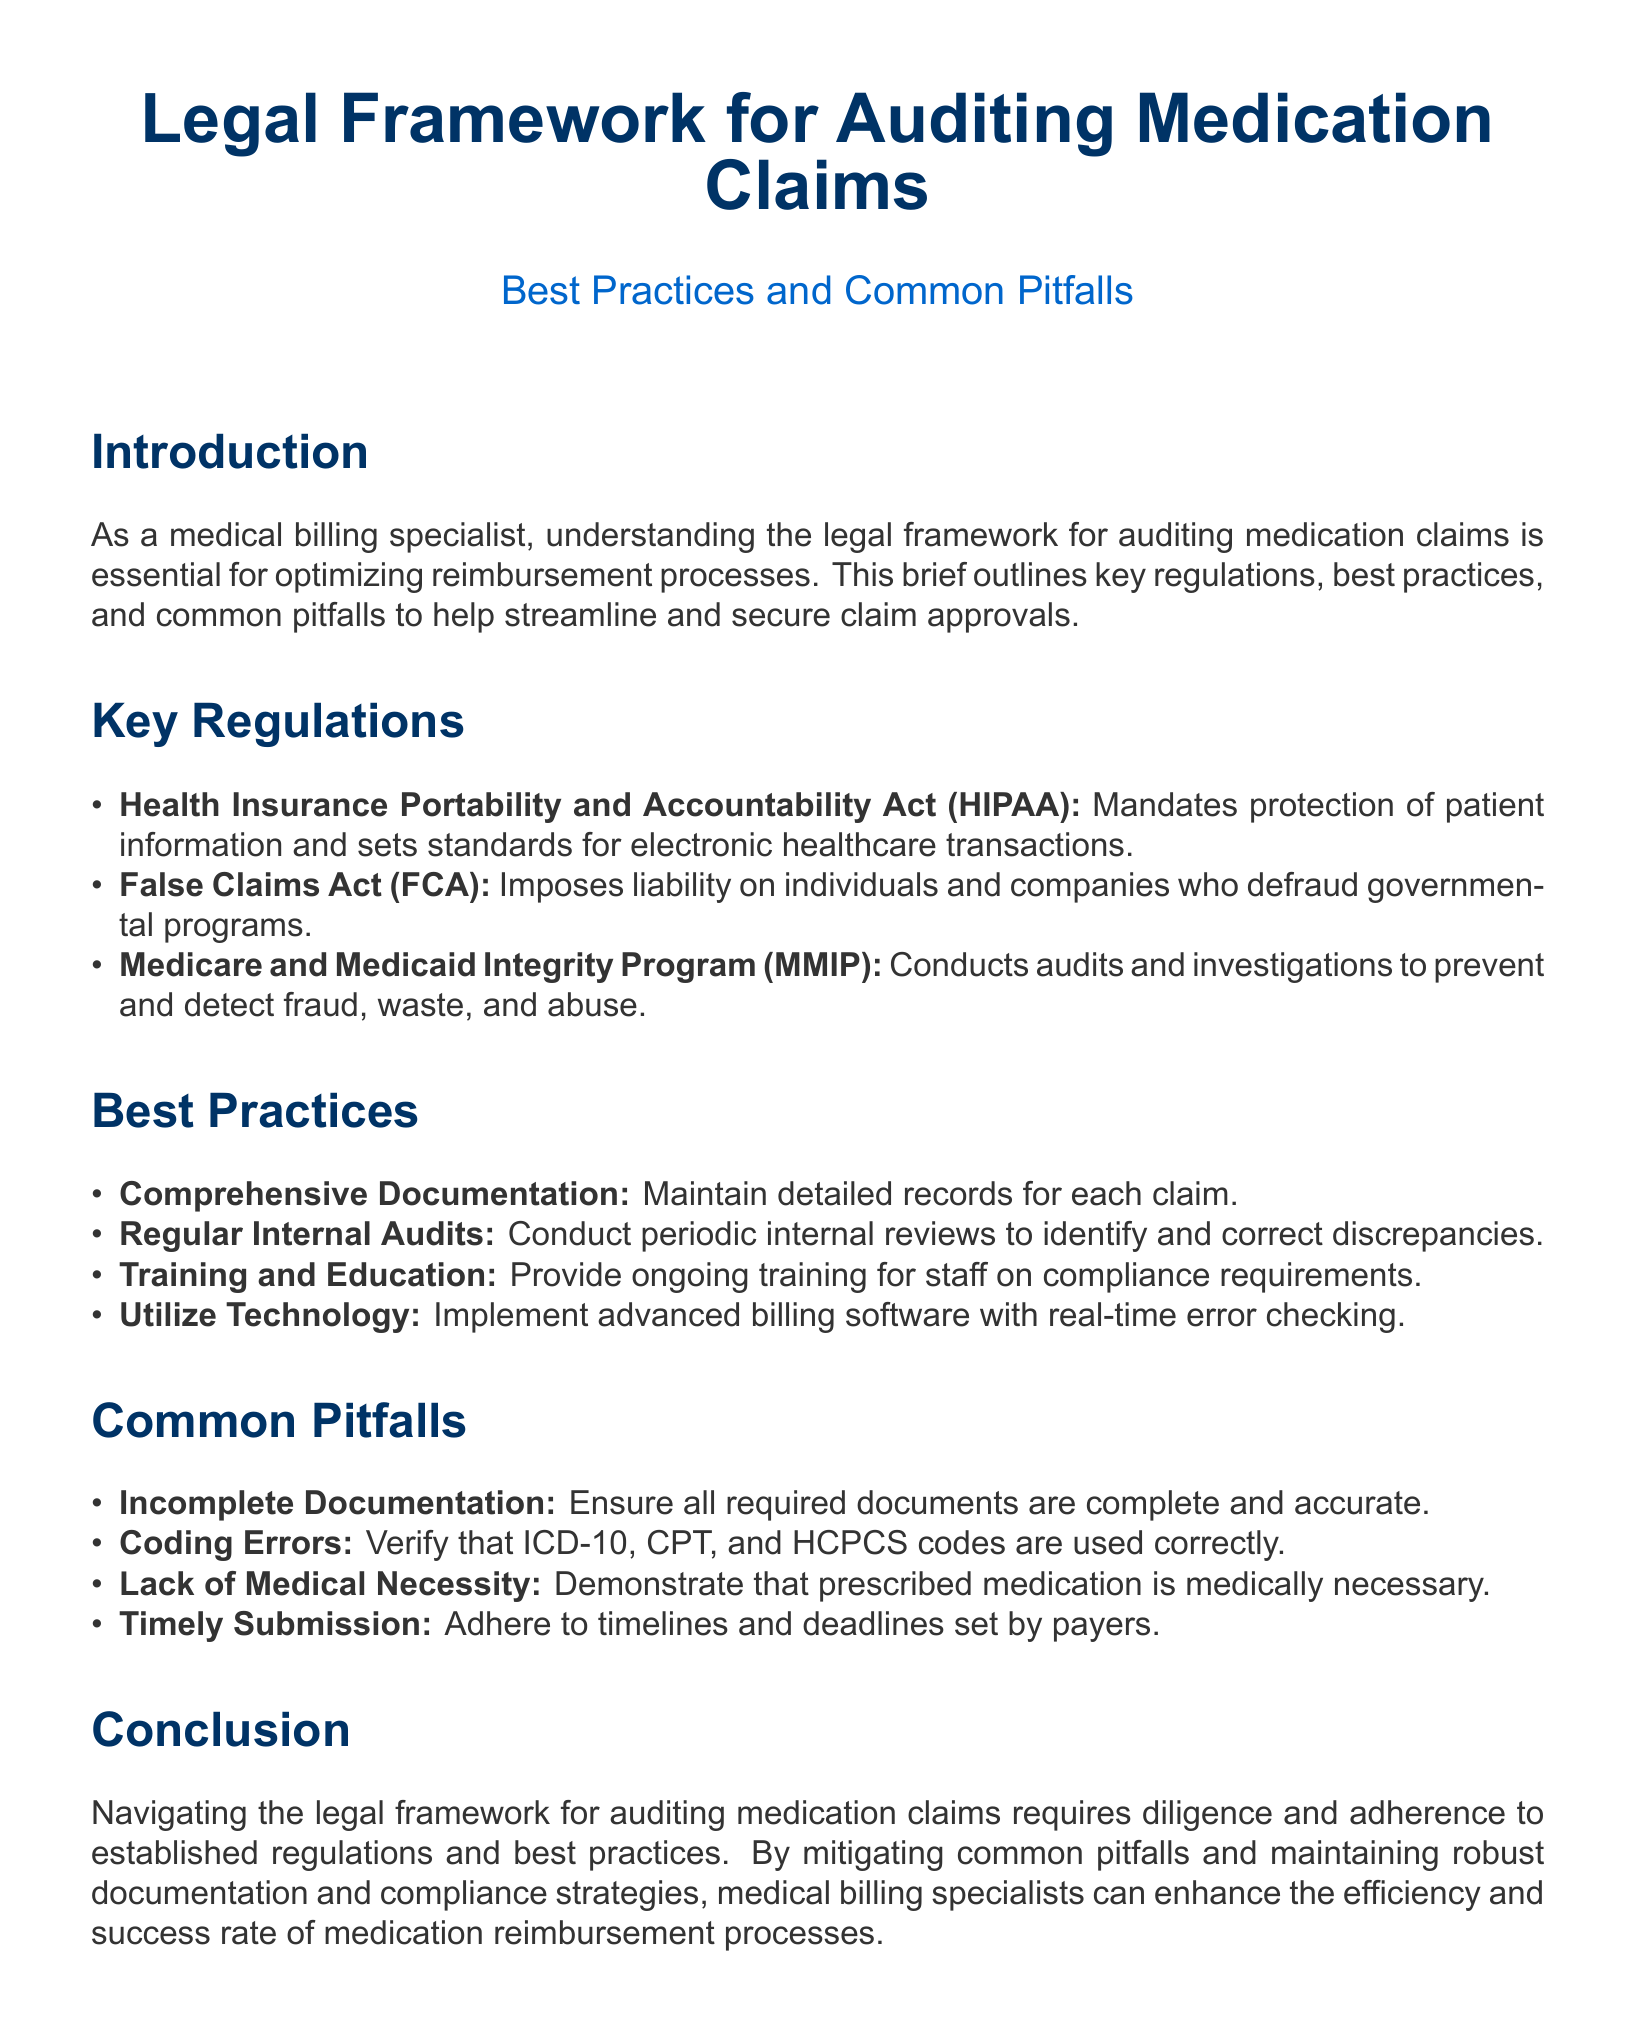What is the main purpose of this legal brief? The brief outlines key regulations, best practices, and common pitfalls to help streamline and secure claim approvals.
Answer: To help streamline and secure claim approvals What does HIPAA stand for? HIPAA is an acronym mentioned in the document representing a significant regulation.
Answer: Health Insurance Portability and Accountability Act What is one of the key regulations related to medication claims auditing? The document lists regulations that are crucial for auditing, including those that prevent fraud.
Answer: False Claims Act What is a best practice for medication claim auditing? The document outlines practices recommended for improving the auditing process.
Answer: Comprehensive Documentation What is a common pitfall to avoid in medication claims? The brief identifies frequent issues that can lead to claim rejection or audit failures.
Answer: Incomplete Documentation How often should internal audits be conducted according to best practices? The brief recommends a frequency for these audits to maintain compliance.
Answer: Regularly What program conducts audits to prevent fraud in Medicare and Medicaid? The document highlights a program specifically designed to maintain integrity in government healthcare programs.
Answer: Medicare and Medicaid Integrity Program What type of training is suggested for staff in this brief? The document emphasizes the importance of education in compliance matters for billing specialists.
Answer: Ongoing training What is the emphasis of the conclusion in the brief? This section summarizes the importance of adherence to practices discussed in the document.
Answer: Diligence and adherence to established regulations 